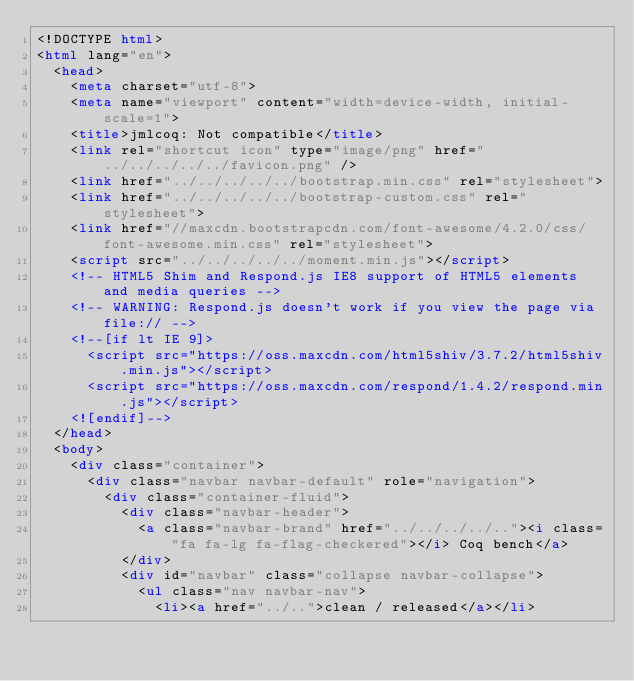<code> <loc_0><loc_0><loc_500><loc_500><_HTML_><!DOCTYPE html>
<html lang="en">
  <head>
    <meta charset="utf-8">
    <meta name="viewport" content="width=device-width, initial-scale=1">
    <title>jmlcoq: Not compatible</title>
    <link rel="shortcut icon" type="image/png" href="../../../../../favicon.png" />
    <link href="../../../../../bootstrap.min.css" rel="stylesheet">
    <link href="../../../../../bootstrap-custom.css" rel="stylesheet">
    <link href="//maxcdn.bootstrapcdn.com/font-awesome/4.2.0/css/font-awesome.min.css" rel="stylesheet">
    <script src="../../../../../moment.min.js"></script>
    <!-- HTML5 Shim and Respond.js IE8 support of HTML5 elements and media queries -->
    <!-- WARNING: Respond.js doesn't work if you view the page via file:// -->
    <!--[if lt IE 9]>
      <script src="https://oss.maxcdn.com/html5shiv/3.7.2/html5shiv.min.js"></script>
      <script src="https://oss.maxcdn.com/respond/1.4.2/respond.min.js"></script>
    <![endif]-->
  </head>
  <body>
    <div class="container">
      <div class="navbar navbar-default" role="navigation">
        <div class="container-fluid">
          <div class="navbar-header">
            <a class="navbar-brand" href="../../../../.."><i class="fa fa-lg fa-flag-checkered"></i> Coq bench</a>
          </div>
          <div id="navbar" class="collapse navbar-collapse">
            <ul class="nav navbar-nav">
              <li><a href="../..">clean / released</a></li></code> 